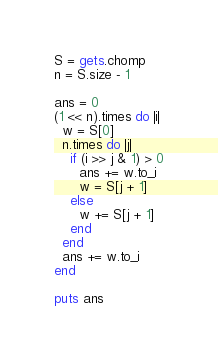<code> <loc_0><loc_0><loc_500><loc_500><_Ruby_>S = gets.chomp
n = S.size - 1

ans = 0
(1 << n).times do |i|
  w = S[0]
  n.times do |j|
    if (i >> j & 1) > 0
      ans += w.to_i
      w = S[j + 1]
    else
      w += S[j + 1]
    end
  end
  ans += w.to_i
end

puts ans
</code> 